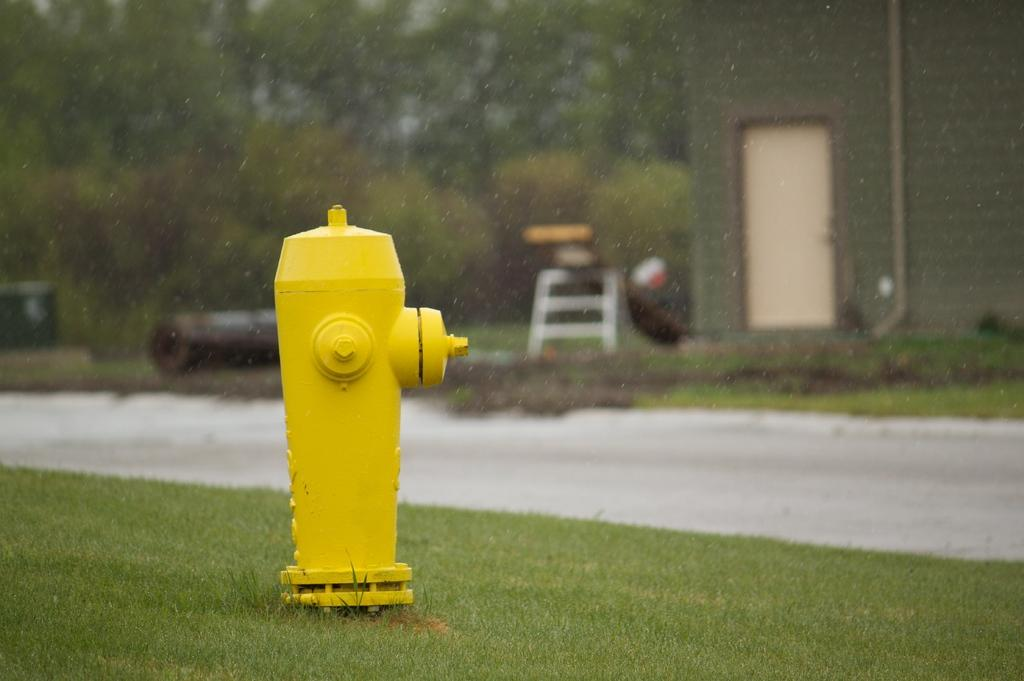What object is the main subject of the image? There is a fire hydrant in the image. What color is the fire hydrant? The fire hydrant is yellow. What can be seen in the background of the image? There is a house, a road, and trees in the background of the image. Can you describe the haircut of the person standing next to the fire hydrant in the image? There is no person standing next to the fire hydrant in the image. Where might one find a drawer in the image? There are no drawers present in the image. 